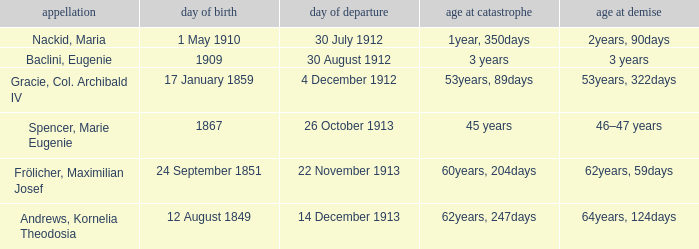How old was the person born 24 September 1851 at the time of disaster? 60years, 204days. 